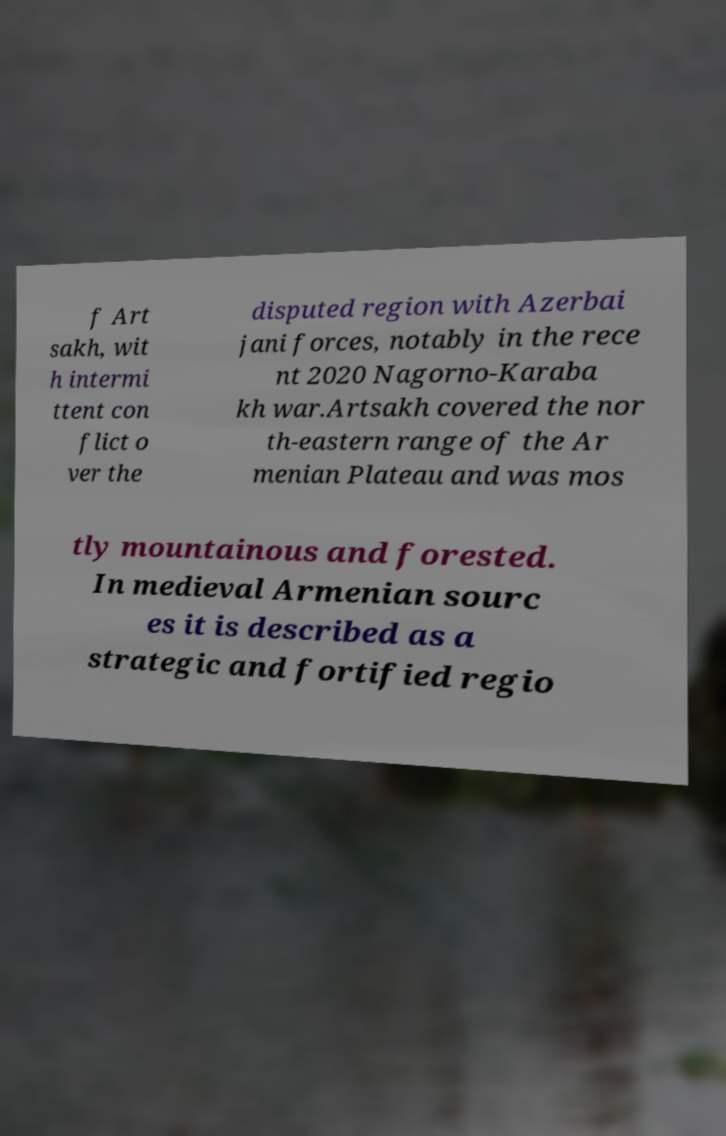For documentation purposes, I need the text within this image transcribed. Could you provide that? f Art sakh, wit h intermi ttent con flict o ver the disputed region with Azerbai jani forces, notably in the rece nt 2020 Nagorno-Karaba kh war.Artsakh covered the nor th-eastern range of the Ar menian Plateau and was mos tly mountainous and forested. In medieval Armenian sourc es it is described as a strategic and fortified regio 